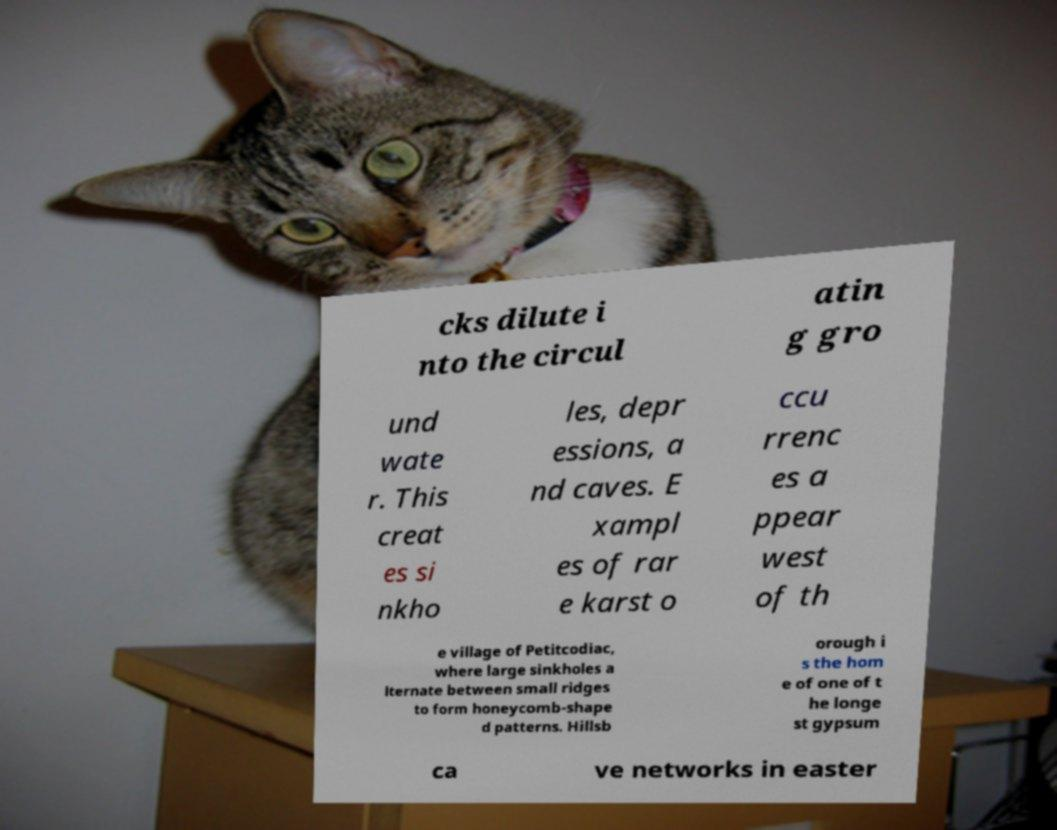There's text embedded in this image that I need extracted. Can you transcribe it verbatim? cks dilute i nto the circul atin g gro und wate r. This creat es si nkho les, depr essions, a nd caves. E xampl es of rar e karst o ccu rrenc es a ppear west of th e village of Petitcodiac, where large sinkholes a lternate between small ridges to form honeycomb-shape d patterns. Hillsb orough i s the hom e of one of t he longe st gypsum ca ve networks in easter 